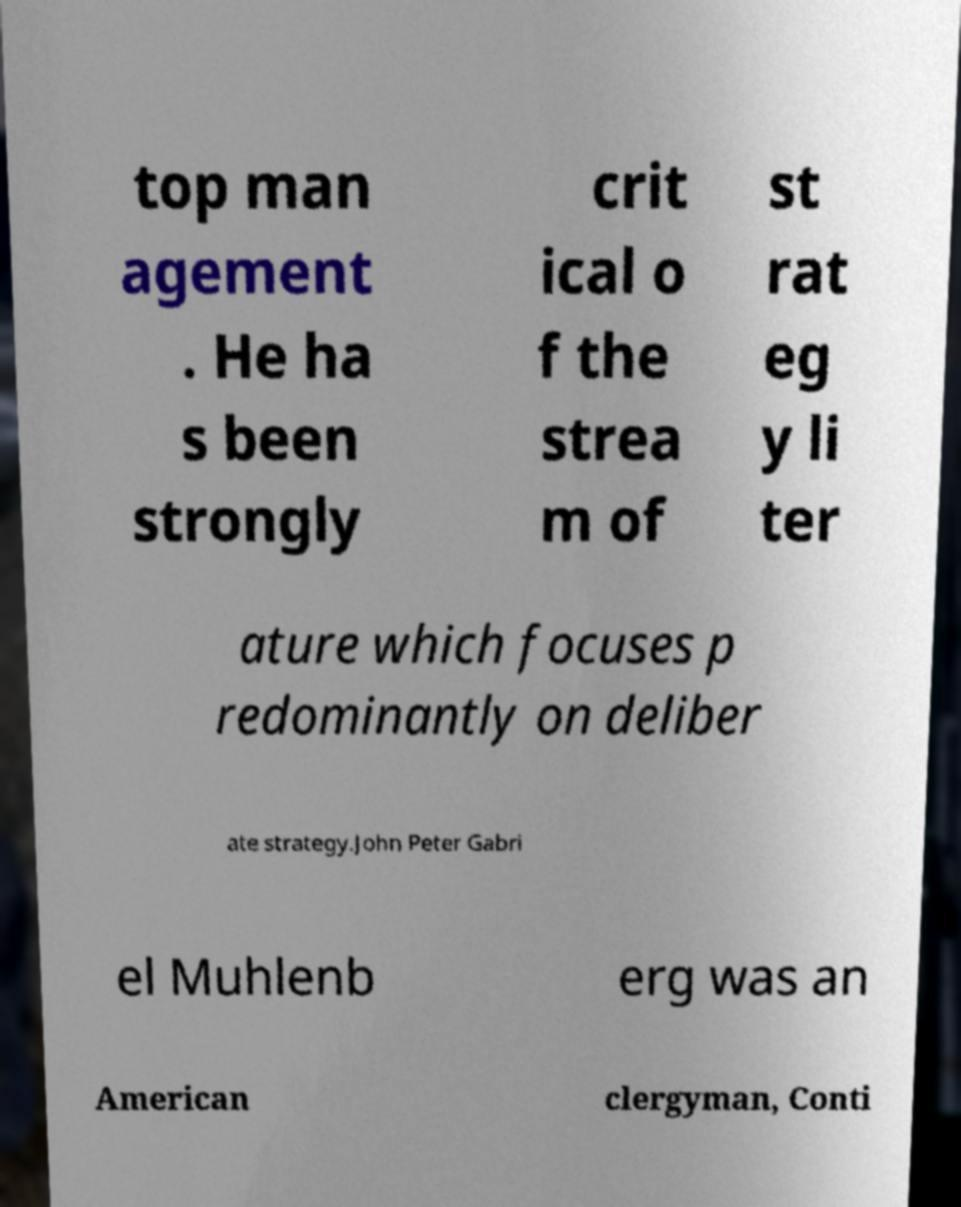Could you assist in decoding the text presented in this image and type it out clearly? top man agement . He ha s been strongly crit ical o f the strea m of st rat eg y li ter ature which focuses p redominantly on deliber ate strategy.John Peter Gabri el Muhlenb erg was an American clergyman, Conti 